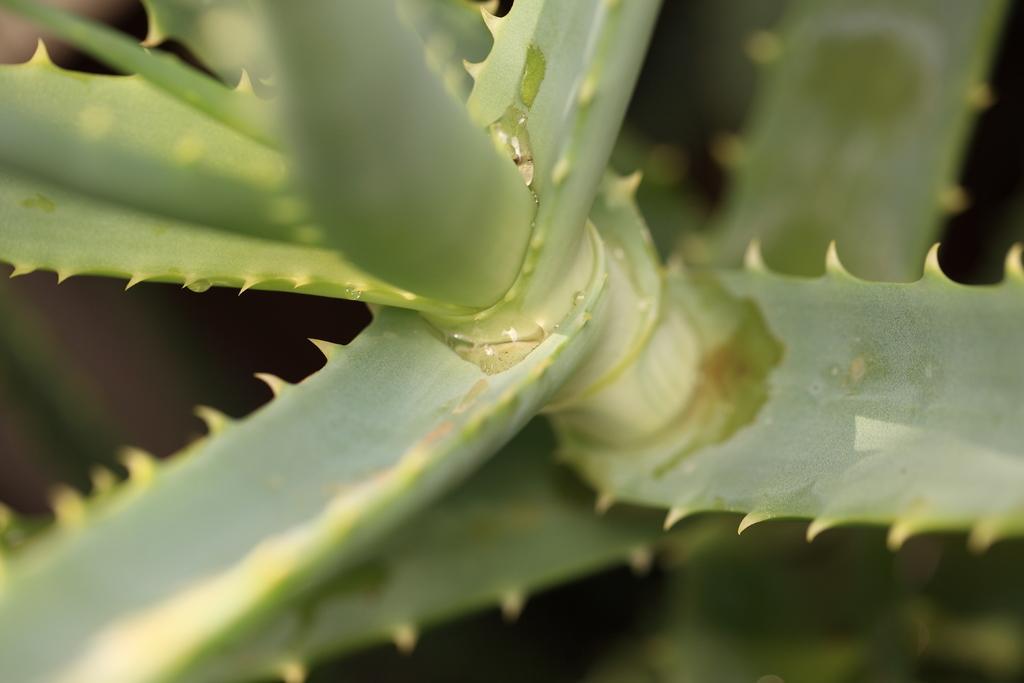How would you summarize this image in a sentence or two? In this image I can see the plant in green color. 